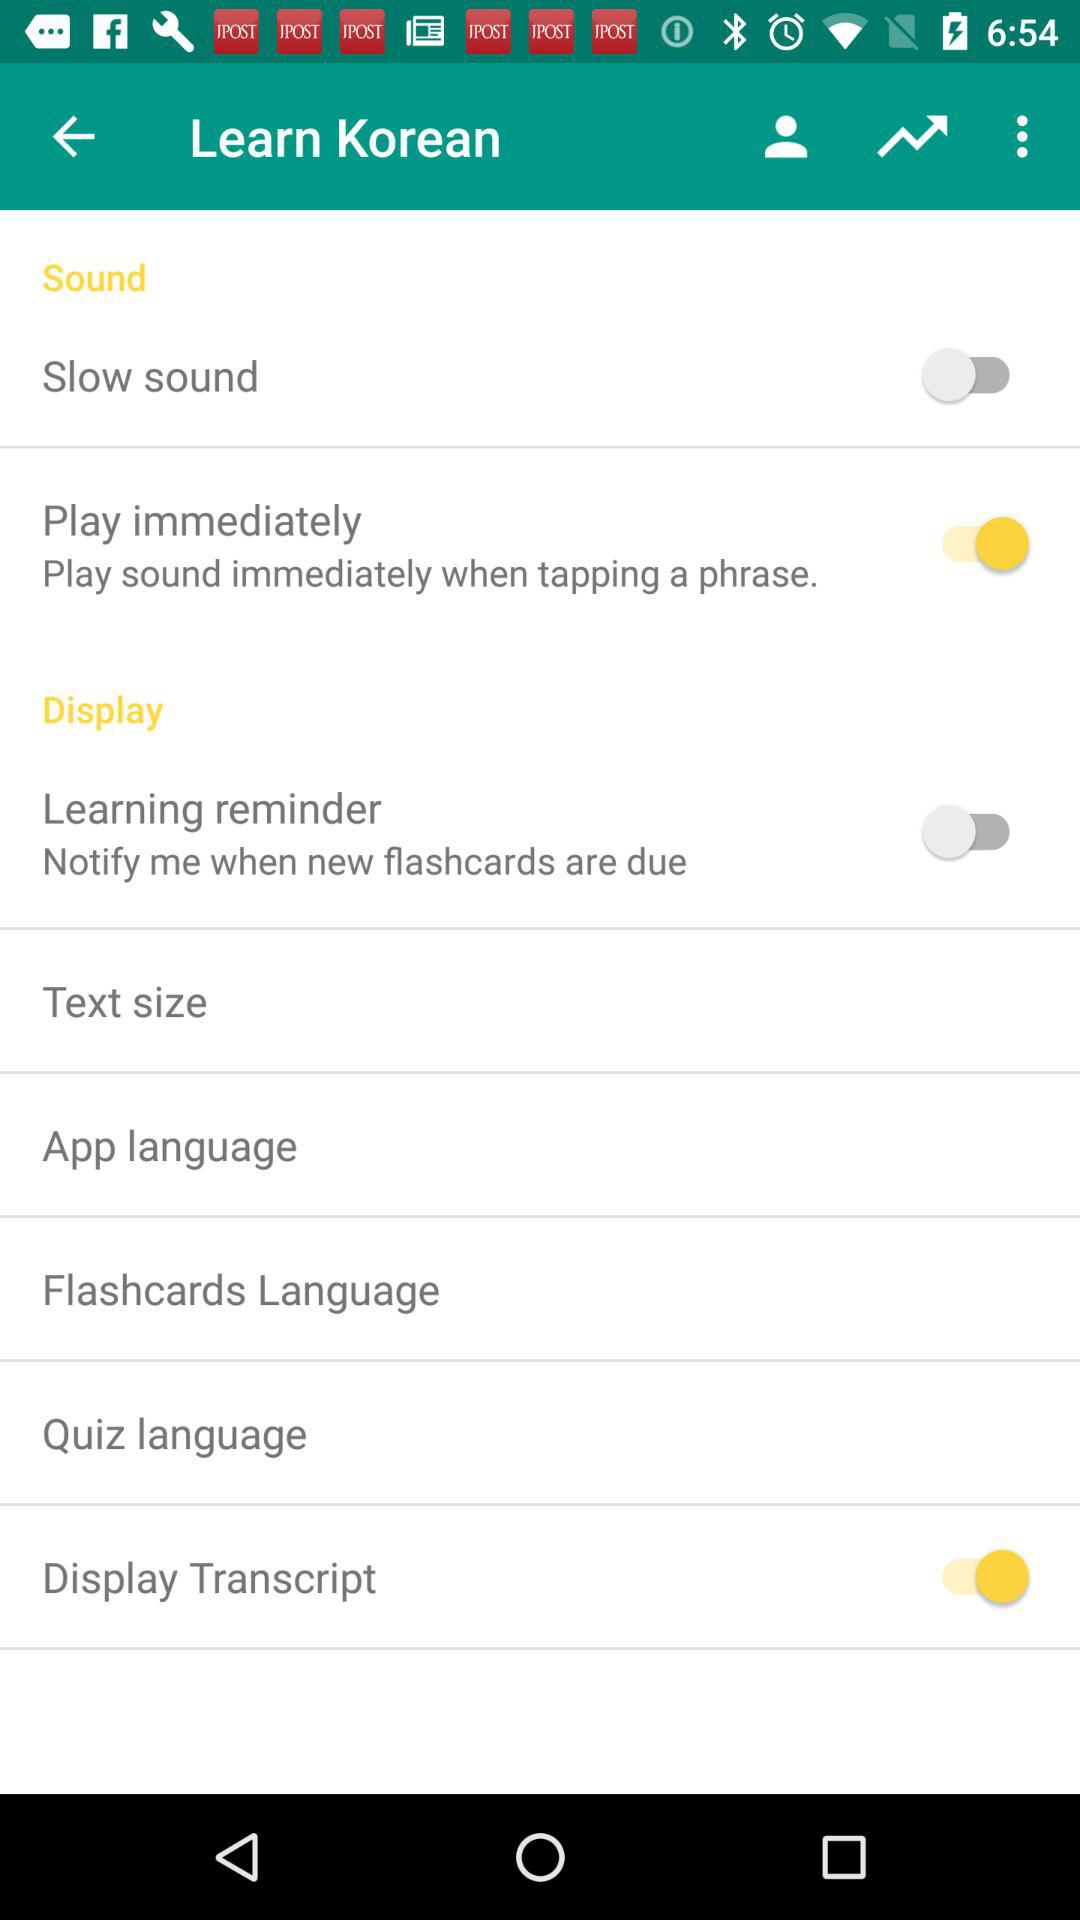What are the options that are disabled? The disabled options are "Slow sound" and "Learning reminder". 